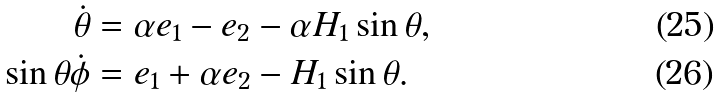Convert formula to latex. <formula><loc_0><loc_0><loc_500><loc_500>\dot { \theta } & = \alpha e _ { 1 } - e _ { 2 } - \alpha H _ { 1 } \sin \theta , \\ \sin \theta \dot { \phi } & = e _ { 1 } + \alpha e _ { 2 } - H _ { 1 } \sin \theta .</formula> 